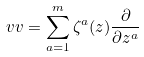Convert formula to latex. <formula><loc_0><loc_0><loc_500><loc_500>\ v v = \sum _ { a = 1 } ^ { m } \zeta ^ { a } ( z ) \frac { \partial } { \partial z ^ { a } }</formula> 